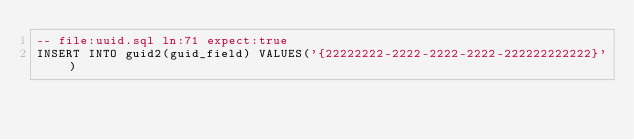Convert code to text. <code><loc_0><loc_0><loc_500><loc_500><_SQL_>-- file:uuid.sql ln:71 expect:true
INSERT INTO guid2(guid_field) VALUES('{22222222-2222-2222-2222-222222222222}')
</code> 